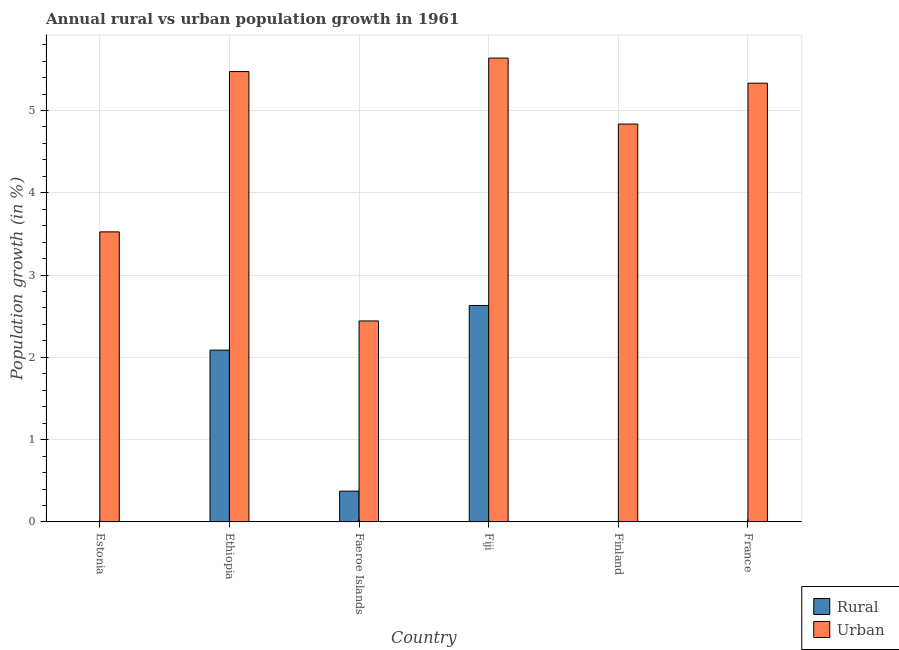Are the number of bars per tick equal to the number of legend labels?
Your response must be concise. No. How many bars are there on the 4th tick from the right?
Your answer should be compact. 2. What is the label of the 4th group of bars from the left?
Keep it short and to the point. Fiji. In how many cases, is the number of bars for a given country not equal to the number of legend labels?
Give a very brief answer. 3. What is the urban population growth in Ethiopia?
Make the answer very short. 5.47. Across all countries, what is the maximum rural population growth?
Provide a succinct answer. 2.63. Across all countries, what is the minimum rural population growth?
Give a very brief answer. 0. In which country was the urban population growth maximum?
Offer a very short reply. Fiji. What is the total rural population growth in the graph?
Offer a very short reply. 5.09. What is the difference between the urban population growth in Ethiopia and that in Fiji?
Provide a short and direct response. -0.16. What is the difference between the rural population growth in Faeroe Islands and the urban population growth in Finland?
Offer a terse response. -4.46. What is the average rural population growth per country?
Provide a succinct answer. 0.85. What is the difference between the urban population growth and rural population growth in Fiji?
Offer a terse response. 3.01. In how many countries, is the urban population growth greater than 2 %?
Ensure brevity in your answer.  6. What is the ratio of the urban population growth in Estonia to that in Ethiopia?
Ensure brevity in your answer.  0.64. Is the urban population growth in Estonia less than that in Finland?
Ensure brevity in your answer.  Yes. What is the difference between the highest and the second highest rural population growth?
Make the answer very short. 0.54. What is the difference between the highest and the lowest rural population growth?
Make the answer very short. 2.63. In how many countries, is the rural population growth greater than the average rural population growth taken over all countries?
Make the answer very short. 2. Are all the bars in the graph horizontal?
Offer a terse response. No. What is the difference between two consecutive major ticks on the Y-axis?
Your answer should be very brief. 1. Are the values on the major ticks of Y-axis written in scientific E-notation?
Your response must be concise. No. Does the graph contain grids?
Your response must be concise. Yes. How many legend labels are there?
Ensure brevity in your answer.  2. What is the title of the graph?
Your response must be concise. Annual rural vs urban population growth in 1961. What is the label or title of the X-axis?
Your answer should be very brief. Country. What is the label or title of the Y-axis?
Offer a terse response. Population growth (in %). What is the Population growth (in %) of Rural in Estonia?
Your answer should be compact. 0. What is the Population growth (in %) in Urban  in Estonia?
Make the answer very short. 3.53. What is the Population growth (in %) of Rural in Ethiopia?
Provide a succinct answer. 2.09. What is the Population growth (in %) of Urban  in Ethiopia?
Provide a short and direct response. 5.47. What is the Population growth (in %) in Rural in Faeroe Islands?
Provide a short and direct response. 0.37. What is the Population growth (in %) of Urban  in Faeroe Islands?
Make the answer very short. 2.44. What is the Population growth (in %) in Rural in Fiji?
Your response must be concise. 2.63. What is the Population growth (in %) in Urban  in Fiji?
Keep it short and to the point. 5.64. What is the Population growth (in %) in Rural in Finland?
Offer a terse response. 0. What is the Population growth (in %) of Urban  in Finland?
Ensure brevity in your answer.  4.84. What is the Population growth (in %) of Rural in France?
Your answer should be compact. 0. What is the Population growth (in %) of Urban  in France?
Provide a succinct answer. 5.33. Across all countries, what is the maximum Population growth (in %) of Rural?
Keep it short and to the point. 2.63. Across all countries, what is the maximum Population growth (in %) of Urban ?
Give a very brief answer. 5.64. Across all countries, what is the minimum Population growth (in %) in Urban ?
Provide a succinct answer. 2.44. What is the total Population growth (in %) in Rural in the graph?
Offer a very short reply. 5.09. What is the total Population growth (in %) of Urban  in the graph?
Make the answer very short. 27.25. What is the difference between the Population growth (in %) in Urban  in Estonia and that in Ethiopia?
Offer a terse response. -1.95. What is the difference between the Population growth (in %) in Urban  in Estonia and that in Faeroe Islands?
Ensure brevity in your answer.  1.08. What is the difference between the Population growth (in %) of Urban  in Estonia and that in Fiji?
Offer a terse response. -2.11. What is the difference between the Population growth (in %) of Urban  in Estonia and that in Finland?
Your response must be concise. -1.31. What is the difference between the Population growth (in %) of Urban  in Estonia and that in France?
Give a very brief answer. -1.81. What is the difference between the Population growth (in %) of Rural in Ethiopia and that in Faeroe Islands?
Your answer should be very brief. 1.71. What is the difference between the Population growth (in %) in Urban  in Ethiopia and that in Faeroe Islands?
Keep it short and to the point. 3.03. What is the difference between the Population growth (in %) in Rural in Ethiopia and that in Fiji?
Your response must be concise. -0.54. What is the difference between the Population growth (in %) of Urban  in Ethiopia and that in Fiji?
Offer a very short reply. -0.16. What is the difference between the Population growth (in %) in Urban  in Ethiopia and that in Finland?
Your answer should be very brief. 0.64. What is the difference between the Population growth (in %) in Urban  in Ethiopia and that in France?
Ensure brevity in your answer.  0.14. What is the difference between the Population growth (in %) of Rural in Faeroe Islands and that in Fiji?
Ensure brevity in your answer.  -2.26. What is the difference between the Population growth (in %) in Urban  in Faeroe Islands and that in Fiji?
Your answer should be very brief. -3.19. What is the difference between the Population growth (in %) in Urban  in Faeroe Islands and that in Finland?
Your answer should be very brief. -2.39. What is the difference between the Population growth (in %) in Urban  in Faeroe Islands and that in France?
Provide a short and direct response. -2.89. What is the difference between the Population growth (in %) of Urban  in Fiji and that in Finland?
Make the answer very short. 0.8. What is the difference between the Population growth (in %) in Urban  in Fiji and that in France?
Provide a succinct answer. 0.31. What is the difference between the Population growth (in %) in Urban  in Finland and that in France?
Keep it short and to the point. -0.5. What is the difference between the Population growth (in %) of Rural in Ethiopia and the Population growth (in %) of Urban  in Faeroe Islands?
Ensure brevity in your answer.  -0.35. What is the difference between the Population growth (in %) of Rural in Ethiopia and the Population growth (in %) of Urban  in Fiji?
Your answer should be compact. -3.55. What is the difference between the Population growth (in %) in Rural in Ethiopia and the Population growth (in %) in Urban  in Finland?
Your response must be concise. -2.75. What is the difference between the Population growth (in %) of Rural in Ethiopia and the Population growth (in %) of Urban  in France?
Your answer should be very brief. -3.24. What is the difference between the Population growth (in %) of Rural in Faeroe Islands and the Population growth (in %) of Urban  in Fiji?
Your response must be concise. -5.26. What is the difference between the Population growth (in %) of Rural in Faeroe Islands and the Population growth (in %) of Urban  in Finland?
Offer a very short reply. -4.46. What is the difference between the Population growth (in %) of Rural in Faeroe Islands and the Population growth (in %) of Urban  in France?
Your answer should be compact. -4.96. What is the difference between the Population growth (in %) of Rural in Fiji and the Population growth (in %) of Urban  in Finland?
Your answer should be very brief. -2.2. What is the difference between the Population growth (in %) of Rural in Fiji and the Population growth (in %) of Urban  in France?
Offer a very short reply. -2.7. What is the average Population growth (in %) of Rural per country?
Your answer should be very brief. 0.85. What is the average Population growth (in %) in Urban  per country?
Ensure brevity in your answer.  4.54. What is the difference between the Population growth (in %) of Rural and Population growth (in %) of Urban  in Ethiopia?
Your answer should be very brief. -3.39. What is the difference between the Population growth (in %) in Rural and Population growth (in %) in Urban  in Faeroe Islands?
Offer a terse response. -2.07. What is the difference between the Population growth (in %) in Rural and Population growth (in %) in Urban  in Fiji?
Your answer should be compact. -3.01. What is the ratio of the Population growth (in %) of Urban  in Estonia to that in Ethiopia?
Your response must be concise. 0.64. What is the ratio of the Population growth (in %) in Urban  in Estonia to that in Faeroe Islands?
Make the answer very short. 1.44. What is the ratio of the Population growth (in %) in Urban  in Estonia to that in Fiji?
Offer a terse response. 0.63. What is the ratio of the Population growth (in %) in Urban  in Estonia to that in Finland?
Make the answer very short. 0.73. What is the ratio of the Population growth (in %) of Urban  in Estonia to that in France?
Make the answer very short. 0.66. What is the ratio of the Population growth (in %) of Rural in Ethiopia to that in Faeroe Islands?
Provide a short and direct response. 5.58. What is the ratio of the Population growth (in %) of Urban  in Ethiopia to that in Faeroe Islands?
Offer a terse response. 2.24. What is the ratio of the Population growth (in %) of Rural in Ethiopia to that in Fiji?
Provide a short and direct response. 0.79. What is the ratio of the Population growth (in %) of Urban  in Ethiopia to that in Fiji?
Your answer should be very brief. 0.97. What is the ratio of the Population growth (in %) of Urban  in Ethiopia to that in Finland?
Offer a very short reply. 1.13. What is the ratio of the Population growth (in %) of Urban  in Ethiopia to that in France?
Give a very brief answer. 1.03. What is the ratio of the Population growth (in %) of Rural in Faeroe Islands to that in Fiji?
Your answer should be very brief. 0.14. What is the ratio of the Population growth (in %) in Urban  in Faeroe Islands to that in Fiji?
Provide a short and direct response. 0.43. What is the ratio of the Population growth (in %) of Urban  in Faeroe Islands to that in Finland?
Make the answer very short. 0.51. What is the ratio of the Population growth (in %) in Urban  in Faeroe Islands to that in France?
Offer a very short reply. 0.46. What is the ratio of the Population growth (in %) in Urban  in Fiji to that in Finland?
Provide a short and direct response. 1.17. What is the ratio of the Population growth (in %) in Urban  in Fiji to that in France?
Make the answer very short. 1.06. What is the ratio of the Population growth (in %) in Urban  in Finland to that in France?
Your response must be concise. 0.91. What is the difference between the highest and the second highest Population growth (in %) of Rural?
Offer a very short reply. 0.54. What is the difference between the highest and the second highest Population growth (in %) in Urban ?
Make the answer very short. 0.16. What is the difference between the highest and the lowest Population growth (in %) of Rural?
Your answer should be compact. 2.63. What is the difference between the highest and the lowest Population growth (in %) in Urban ?
Keep it short and to the point. 3.19. 